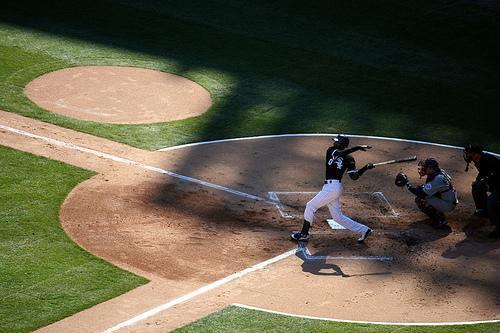How many circles are seen?
Give a very brief answer. 2. How many people are there?
Give a very brief answer. 3. How many bases are in the photo?
Give a very brief answer. 1. 